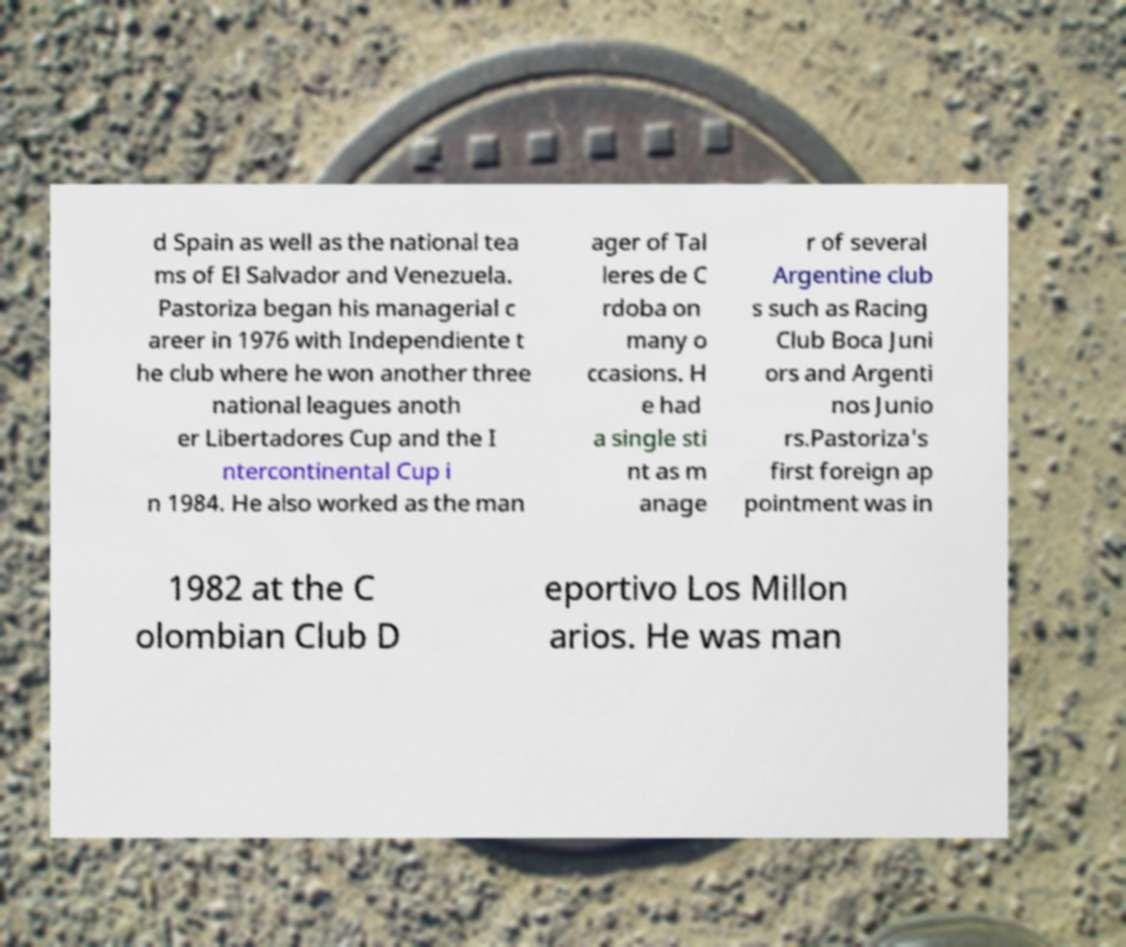Could you assist in decoding the text presented in this image and type it out clearly? d Spain as well as the national tea ms of El Salvador and Venezuela. Pastoriza began his managerial c areer in 1976 with Independiente t he club where he won another three national leagues anoth er Libertadores Cup and the I ntercontinental Cup i n 1984. He also worked as the man ager of Tal leres de C rdoba on many o ccasions. H e had a single sti nt as m anage r of several Argentine club s such as Racing Club Boca Juni ors and Argenti nos Junio rs.Pastoriza's first foreign ap pointment was in 1982 at the C olombian Club D eportivo Los Millon arios. He was man 